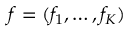<formula> <loc_0><loc_0><loc_500><loc_500>f = ( f _ { 1 } , \dots , f _ { K } )</formula> 